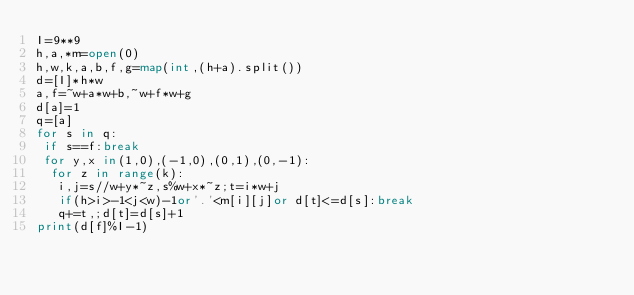<code> <loc_0><loc_0><loc_500><loc_500><_Python_>I=9**9
h,a,*m=open(0)
h,w,k,a,b,f,g=map(int,(h+a).split())
d=[I]*h*w
a,f=~w+a*w+b,~w+f*w+g
d[a]=1
q=[a]
for s in q:
 if s==f:break
 for y,x in(1,0),(-1,0),(0,1),(0,-1):
  for z in range(k):
   i,j=s//w+y*~z,s%w+x*~z;t=i*w+j
   if(h>i>-1<j<w)-1or'.'<m[i][j]or d[t]<=d[s]:break
   q+=t,;d[t]=d[s]+1
print(d[f]%I-1)</code> 